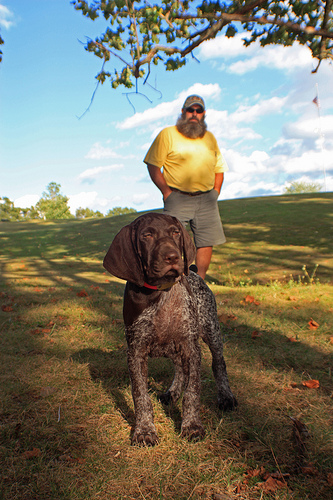Please provide a short description for this region: [0.44, 0.25, 0.63, 0.39]. This area captures a close-up of a bright yellow shirt worn by a man standing in a grassy outdoor setting. 